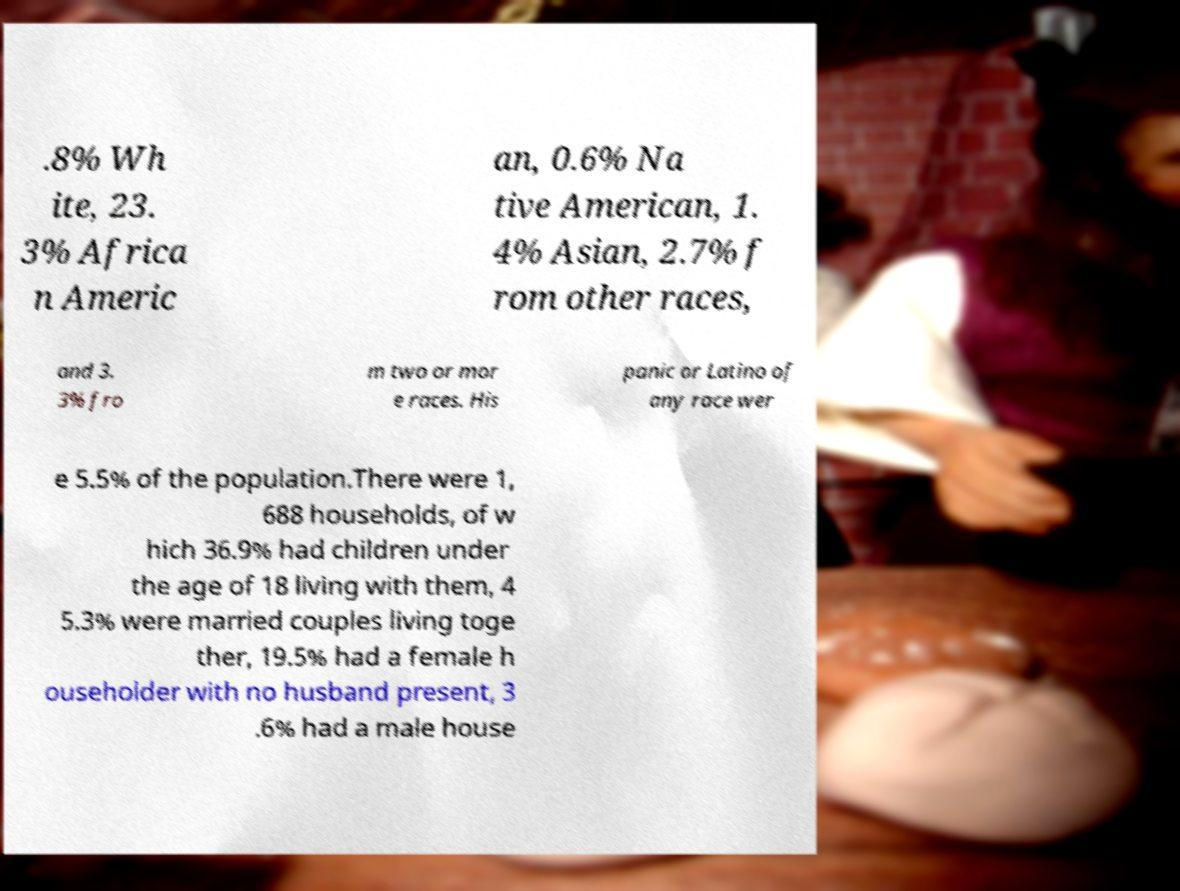For documentation purposes, I need the text within this image transcribed. Could you provide that? .8% Wh ite, 23. 3% Africa n Americ an, 0.6% Na tive American, 1. 4% Asian, 2.7% f rom other races, and 3. 3% fro m two or mor e races. His panic or Latino of any race wer e 5.5% of the population.There were 1, 688 households, of w hich 36.9% had children under the age of 18 living with them, 4 5.3% were married couples living toge ther, 19.5% had a female h ouseholder with no husband present, 3 .6% had a male house 